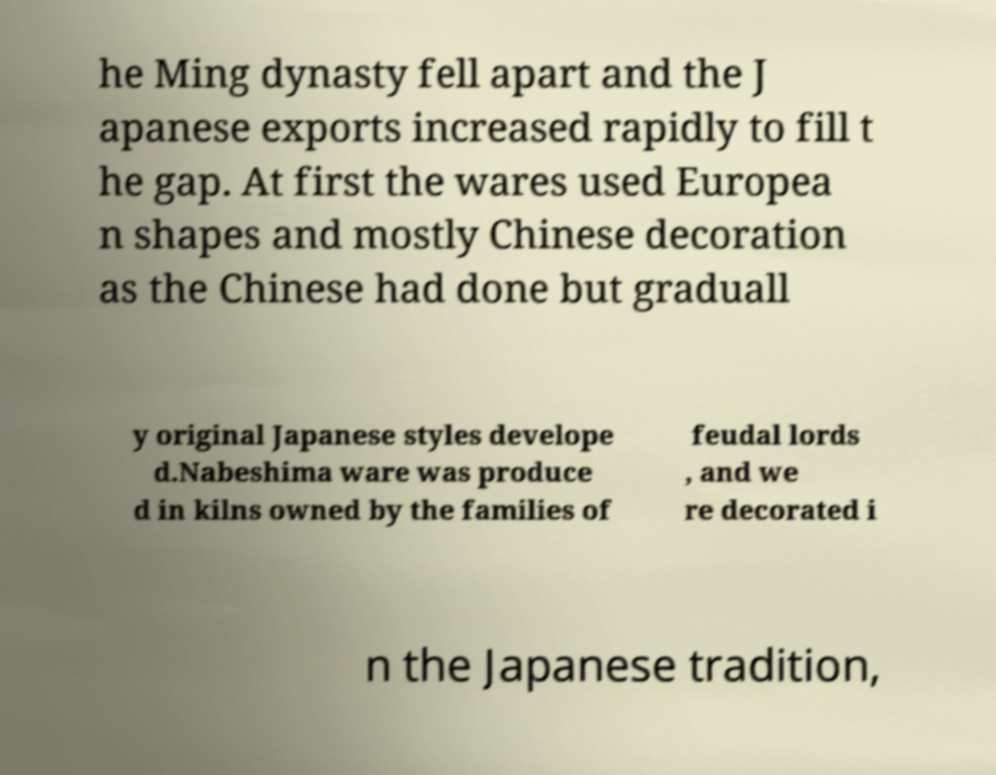Please read and relay the text visible in this image. What does it say? he Ming dynasty fell apart and the J apanese exports increased rapidly to fill t he gap. At first the wares used Europea n shapes and mostly Chinese decoration as the Chinese had done but graduall y original Japanese styles develope d.Nabeshima ware was produce d in kilns owned by the families of feudal lords , and we re decorated i n the Japanese tradition, 